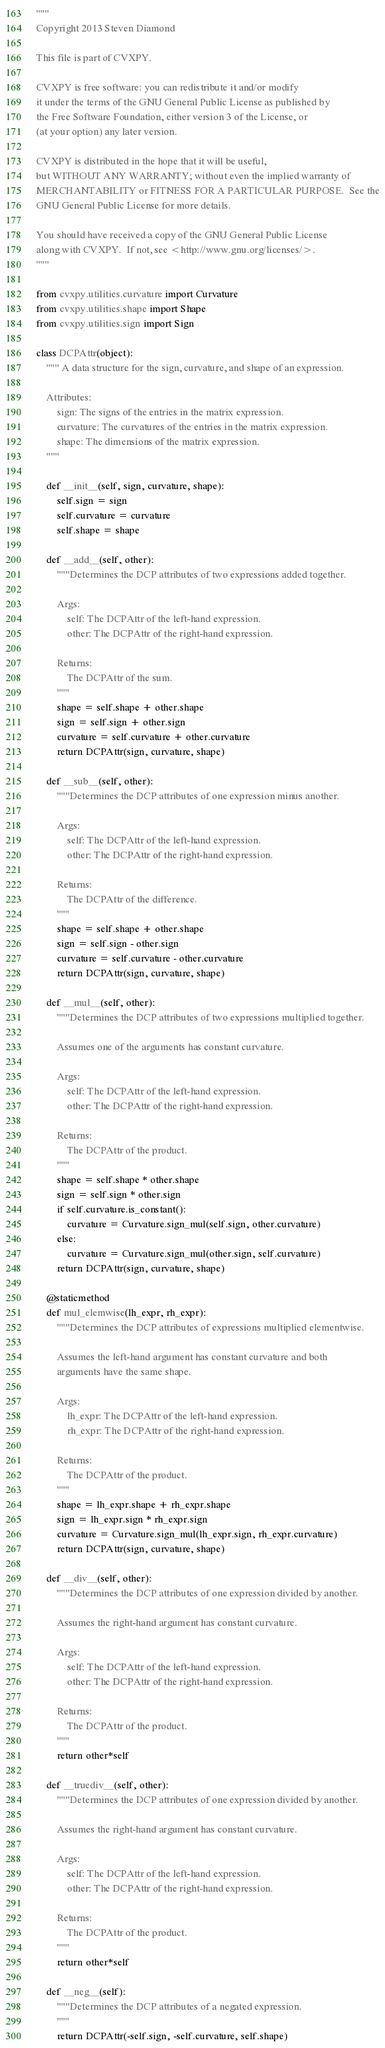<code> <loc_0><loc_0><loc_500><loc_500><_Python_>"""
Copyright 2013 Steven Diamond

This file is part of CVXPY.

CVXPY is free software: you can redistribute it and/or modify
it under the terms of the GNU General Public License as published by
the Free Software Foundation, either version 3 of the License, or
(at your option) any later version.

CVXPY is distributed in the hope that it will be useful,
but WITHOUT ANY WARRANTY; without even the implied warranty of
MERCHANTABILITY or FITNESS FOR A PARTICULAR PURPOSE.  See the
GNU General Public License for more details.

You should have received a copy of the GNU General Public License
along with CVXPY.  If not, see <http://www.gnu.org/licenses/>.
"""

from cvxpy.utilities.curvature import Curvature
from cvxpy.utilities.shape import Shape
from cvxpy.utilities.sign import Sign

class DCPAttr(object):
    """ A data structure for the sign, curvature, and shape of an expression.

    Attributes:
        sign: The signs of the entries in the matrix expression.
        curvature: The curvatures of the entries in the matrix expression.
        shape: The dimensions of the matrix expression.
    """

    def __init__(self, sign, curvature, shape):
        self.sign = sign
        self.curvature = curvature
        self.shape = shape

    def __add__(self, other):
        """Determines the DCP attributes of two expressions added together.

        Args:
            self: The DCPAttr of the left-hand expression.
            other: The DCPAttr of the right-hand expression.

        Returns:
            The DCPAttr of the sum.
        """
        shape = self.shape + other.shape
        sign = self.sign + other.sign
        curvature = self.curvature + other.curvature
        return DCPAttr(sign, curvature, shape)

    def __sub__(self, other):
        """Determines the DCP attributes of one expression minus another.

        Args:
            self: The DCPAttr of the left-hand expression.
            other: The DCPAttr of the right-hand expression.

        Returns:
            The DCPAttr of the difference.
        """
        shape = self.shape + other.shape
        sign = self.sign - other.sign
        curvature = self.curvature - other.curvature
        return DCPAttr(sign, curvature, shape)

    def __mul__(self, other):
        """Determines the DCP attributes of two expressions multiplied together.

        Assumes one of the arguments has constant curvature.

        Args:
            self: The DCPAttr of the left-hand expression.
            other: The DCPAttr of the right-hand expression.

        Returns:
            The DCPAttr of the product.
        """
        shape = self.shape * other.shape
        sign = self.sign * other.sign
        if self.curvature.is_constant():
            curvature = Curvature.sign_mul(self.sign, other.curvature)
        else:
            curvature = Curvature.sign_mul(other.sign, self.curvature)
        return DCPAttr(sign, curvature, shape)

    @staticmethod
    def mul_elemwise(lh_expr, rh_expr):
        """Determines the DCP attributes of expressions multiplied elementwise.

        Assumes the left-hand argument has constant curvature and both
        arguments have the same shape.

        Args:
            lh_expr: The DCPAttr of the left-hand expression.
            rh_expr: The DCPAttr of the right-hand expression.

        Returns:
            The DCPAttr of the product.
        """
        shape = lh_expr.shape + rh_expr.shape
        sign = lh_expr.sign * rh_expr.sign
        curvature = Curvature.sign_mul(lh_expr.sign, rh_expr.curvature)
        return DCPAttr(sign, curvature, shape)

    def __div__(self, other):
        """Determines the DCP attributes of one expression divided by another.

        Assumes the right-hand argument has constant curvature.

        Args:
            self: The DCPAttr of the left-hand expression.
            other: The DCPAttr of the right-hand expression.

        Returns:
            The DCPAttr of the product.
        """
        return other*self

    def __truediv__(self, other):
        """Determines the DCP attributes of one expression divided by another.

        Assumes the right-hand argument has constant curvature.

        Args:
            self: The DCPAttr of the left-hand expression.
            other: The DCPAttr of the right-hand expression.

        Returns:
            The DCPAttr of the product.
        """
        return other*self

    def __neg__(self):
        """Determines the DCP attributes of a negated expression.
        """
        return DCPAttr(-self.sign, -self.curvature, self.shape)
</code> 